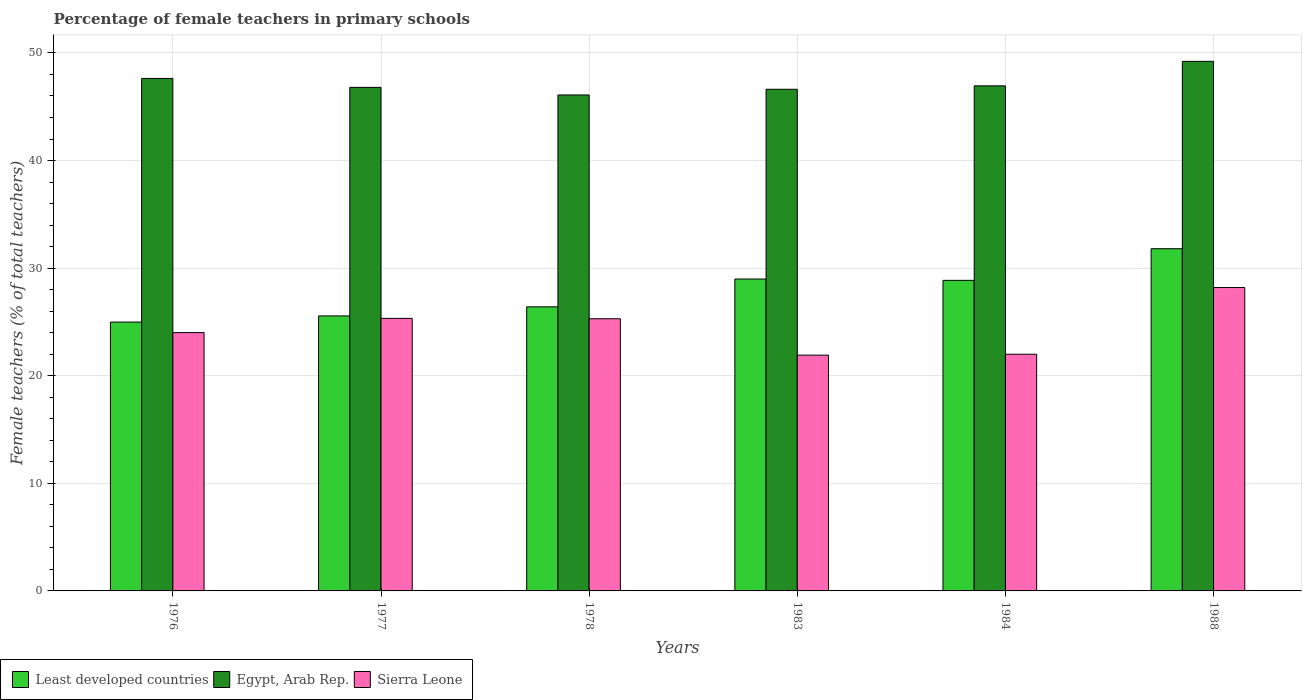How many different coloured bars are there?
Offer a terse response. 3. How many groups of bars are there?
Your answer should be compact. 6. Are the number of bars per tick equal to the number of legend labels?
Provide a short and direct response. Yes. Are the number of bars on each tick of the X-axis equal?
Provide a short and direct response. Yes. In how many cases, is the number of bars for a given year not equal to the number of legend labels?
Your answer should be compact. 0. What is the percentage of female teachers in Egypt, Arab Rep. in 1983?
Keep it short and to the point. 46.62. Across all years, what is the maximum percentage of female teachers in Sierra Leone?
Ensure brevity in your answer.  28.2. Across all years, what is the minimum percentage of female teachers in Least developed countries?
Provide a succinct answer. 24.98. In which year was the percentage of female teachers in Sierra Leone maximum?
Your answer should be very brief. 1988. In which year was the percentage of female teachers in Least developed countries minimum?
Give a very brief answer. 1976. What is the total percentage of female teachers in Sierra Leone in the graph?
Offer a terse response. 146.74. What is the difference between the percentage of female teachers in Egypt, Arab Rep. in 1977 and that in 1983?
Your response must be concise. 0.18. What is the difference between the percentage of female teachers in Least developed countries in 1977 and the percentage of female teachers in Egypt, Arab Rep. in 1976?
Your answer should be compact. -22.07. What is the average percentage of female teachers in Least developed countries per year?
Give a very brief answer. 27.77. In the year 1983, what is the difference between the percentage of female teachers in Egypt, Arab Rep. and percentage of female teachers in Least developed countries?
Your response must be concise. 17.64. In how many years, is the percentage of female teachers in Least developed countries greater than 34 %?
Your response must be concise. 0. What is the ratio of the percentage of female teachers in Sierra Leone in 1977 to that in 1983?
Give a very brief answer. 1.16. Is the difference between the percentage of female teachers in Egypt, Arab Rep. in 1976 and 1984 greater than the difference between the percentage of female teachers in Least developed countries in 1976 and 1984?
Provide a short and direct response. Yes. What is the difference between the highest and the second highest percentage of female teachers in Egypt, Arab Rep.?
Provide a short and direct response. 1.59. What is the difference between the highest and the lowest percentage of female teachers in Least developed countries?
Your response must be concise. 6.82. In how many years, is the percentage of female teachers in Sierra Leone greater than the average percentage of female teachers in Sierra Leone taken over all years?
Your answer should be very brief. 3. Is the sum of the percentage of female teachers in Least developed countries in 1977 and 1983 greater than the maximum percentage of female teachers in Sierra Leone across all years?
Your response must be concise. Yes. What does the 1st bar from the left in 1976 represents?
Your response must be concise. Least developed countries. What does the 2nd bar from the right in 1976 represents?
Give a very brief answer. Egypt, Arab Rep. What is the difference between two consecutive major ticks on the Y-axis?
Your answer should be very brief. 10. Does the graph contain any zero values?
Offer a very short reply. No. Does the graph contain grids?
Provide a succinct answer. Yes. Where does the legend appear in the graph?
Provide a short and direct response. Bottom left. How many legend labels are there?
Your response must be concise. 3. How are the legend labels stacked?
Ensure brevity in your answer.  Horizontal. What is the title of the graph?
Provide a succinct answer. Percentage of female teachers in primary schools. What is the label or title of the Y-axis?
Keep it short and to the point. Female teachers (% of total teachers). What is the Female teachers (% of total teachers) in Least developed countries in 1976?
Provide a short and direct response. 24.98. What is the Female teachers (% of total teachers) in Egypt, Arab Rep. in 1976?
Offer a terse response. 47.63. What is the Female teachers (% of total teachers) of Sierra Leone in 1976?
Make the answer very short. 24.01. What is the Female teachers (% of total teachers) in Least developed countries in 1977?
Your answer should be compact. 25.56. What is the Female teachers (% of total teachers) of Egypt, Arab Rep. in 1977?
Your answer should be very brief. 46.8. What is the Female teachers (% of total teachers) of Sierra Leone in 1977?
Keep it short and to the point. 25.33. What is the Female teachers (% of total teachers) in Least developed countries in 1978?
Your response must be concise. 26.4. What is the Female teachers (% of total teachers) of Egypt, Arab Rep. in 1978?
Ensure brevity in your answer.  46.09. What is the Female teachers (% of total teachers) in Sierra Leone in 1978?
Ensure brevity in your answer.  25.3. What is the Female teachers (% of total teachers) of Least developed countries in 1983?
Offer a terse response. 28.99. What is the Female teachers (% of total teachers) in Egypt, Arab Rep. in 1983?
Your answer should be compact. 46.62. What is the Female teachers (% of total teachers) in Sierra Leone in 1983?
Your answer should be very brief. 21.91. What is the Female teachers (% of total teachers) in Least developed countries in 1984?
Make the answer very short. 28.86. What is the Female teachers (% of total teachers) in Egypt, Arab Rep. in 1984?
Make the answer very short. 46.94. What is the Female teachers (% of total teachers) of Sierra Leone in 1984?
Your response must be concise. 22. What is the Female teachers (% of total teachers) in Least developed countries in 1988?
Your answer should be very brief. 31.8. What is the Female teachers (% of total teachers) in Egypt, Arab Rep. in 1988?
Provide a succinct answer. 49.22. What is the Female teachers (% of total teachers) in Sierra Leone in 1988?
Your answer should be compact. 28.2. Across all years, what is the maximum Female teachers (% of total teachers) in Least developed countries?
Provide a succinct answer. 31.8. Across all years, what is the maximum Female teachers (% of total teachers) of Egypt, Arab Rep.?
Your answer should be very brief. 49.22. Across all years, what is the maximum Female teachers (% of total teachers) in Sierra Leone?
Your answer should be compact. 28.2. Across all years, what is the minimum Female teachers (% of total teachers) in Least developed countries?
Keep it short and to the point. 24.98. Across all years, what is the minimum Female teachers (% of total teachers) in Egypt, Arab Rep.?
Keep it short and to the point. 46.09. Across all years, what is the minimum Female teachers (% of total teachers) of Sierra Leone?
Keep it short and to the point. 21.91. What is the total Female teachers (% of total teachers) of Least developed countries in the graph?
Ensure brevity in your answer.  166.6. What is the total Female teachers (% of total teachers) in Egypt, Arab Rep. in the graph?
Your answer should be compact. 283.3. What is the total Female teachers (% of total teachers) in Sierra Leone in the graph?
Offer a terse response. 146.74. What is the difference between the Female teachers (% of total teachers) in Least developed countries in 1976 and that in 1977?
Offer a very short reply. -0.57. What is the difference between the Female teachers (% of total teachers) in Egypt, Arab Rep. in 1976 and that in 1977?
Your response must be concise. 0.83. What is the difference between the Female teachers (% of total teachers) in Sierra Leone in 1976 and that in 1977?
Make the answer very short. -1.32. What is the difference between the Female teachers (% of total teachers) of Least developed countries in 1976 and that in 1978?
Ensure brevity in your answer.  -1.42. What is the difference between the Female teachers (% of total teachers) of Egypt, Arab Rep. in 1976 and that in 1978?
Give a very brief answer. 1.54. What is the difference between the Female teachers (% of total teachers) in Sierra Leone in 1976 and that in 1978?
Give a very brief answer. -1.29. What is the difference between the Female teachers (% of total teachers) of Least developed countries in 1976 and that in 1983?
Keep it short and to the point. -4. What is the difference between the Female teachers (% of total teachers) in Egypt, Arab Rep. in 1976 and that in 1983?
Keep it short and to the point. 1.01. What is the difference between the Female teachers (% of total teachers) of Sierra Leone in 1976 and that in 1983?
Your answer should be compact. 2.1. What is the difference between the Female teachers (% of total teachers) in Least developed countries in 1976 and that in 1984?
Offer a terse response. -3.88. What is the difference between the Female teachers (% of total teachers) in Egypt, Arab Rep. in 1976 and that in 1984?
Your answer should be very brief. 0.69. What is the difference between the Female teachers (% of total teachers) of Sierra Leone in 1976 and that in 1984?
Make the answer very short. 2.01. What is the difference between the Female teachers (% of total teachers) in Least developed countries in 1976 and that in 1988?
Your response must be concise. -6.82. What is the difference between the Female teachers (% of total teachers) of Egypt, Arab Rep. in 1976 and that in 1988?
Keep it short and to the point. -1.59. What is the difference between the Female teachers (% of total teachers) of Sierra Leone in 1976 and that in 1988?
Give a very brief answer. -4.19. What is the difference between the Female teachers (% of total teachers) of Least developed countries in 1977 and that in 1978?
Your answer should be compact. -0.84. What is the difference between the Female teachers (% of total teachers) of Egypt, Arab Rep. in 1977 and that in 1978?
Ensure brevity in your answer.  0.7. What is the difference between the Female teachers (% of total teachers) of Sierra Leone in 1977 and that in 1978?
Provide a succinct answer. 0.04. What is the difference between the Female teachers (% of total teachers) of Least developed countries in 1977 and that in 1983?
Your answer should be compact. -3.43. What is the difference between the Female teachers (% of total teachers) in Egypt, Arab Rep. in 1977 and that in 1983?
Provide a short and direct response. 0.18. What is the difference between the Female teachers (% of total teachers) in Sierra Leone in 1977 and that in 1983?
Offer a very short reply. 3.42. What is the difference between the Female teachers (% of total teachers) in Least developed countries in 1977 and that in 1984?
Your answer should be very brief. -3.31. What is the difference between the Female teachers (% of total teachers) of Egypt, Arab Rep. in 1977 and that in 1984?
Provide a short and direct response. -0.14. What is the difference between the Female teachers (% of total teachers) of Sierra Leone in 1977 and that in 1984?
Provide a succinct answer. 3.34. What is the difference between the Female teachers (% of total teachers) of Least developed countries in 1977 and that in 1988?
Offer a very short reply. -6.24. What is the difference between the Female teachers (% of total teachers) of Egypt, Arab Rep. in 1977 and that in 1988?
Ensure brevity in your answer.  -2.42. What is the difference between the Female teachers (% of total teachers) in Sierra Leone in 1977 and that in 1988?
Ensure brevity in your answer.  -2.87. What is the difference between the Female teachers (% of total teachers) of Least developed countries in 1978 and that in 1983?
Offer a very short reply. -2.58. What is the difference between the Female teachers (% of total teachers) of Egypt, Arab Rep. in 1978 and that in 1983?
Your answer should be very brief. -0.53. What is the difference between the Female teachers (% of total teachers) of Sierra Leone in 1978 and that in 1983?
Keep it short and to the point. 3.38. What is the difference between the Female teachers (% of total teachers) in Least developed countries in 1978 and that in 1984?
Make the answer very short. -2.46. What is the difference between the Female teachers (% of total teachers) in Egypt, Arab Rep. in 1978 and that in 1984?
Your answer should be very brief. -0.85. What is the difference between the Female teachers (% of total teachers) in Least developed countries in 1978 and that in 1988?
Provide a short and direct response. -5.4. What is the difference between the Female teachers (% of total teachers) in Egypt, Arab Rep. in 1978 and that in 1988?
Your answer should be compact. -3.12. What is the difference between the Female teachers (% of total teachers) of Sierra Leone in 1978 and that in 1988?
Your response must be concise. -2.9. What is the difference between the Female teachers (% of total teachers) in Least developed countries in 1983 and that in 1984?
Make the answer very short. 0.12. What is the difference between the Female teachers (% of total teachers) in Egypt, Arab Rep. in 1983 and that in 1984?
Your answer should be compact. -0.32. What is the difference between the Female teachers (% of total teachers) in Sierra Leone in 1983 and that in 1984?
Your answer should be compact. -0.08. What is the difference between the Female teachers (% of total teachers) of Least developed countries in 1983 and that in 1988?
Keep it short and to the point. -2.82. What is the difference between the Female teachers (% of total teachers) of Egypt, Arab Rep. in 1983 and that in 1988?
Your answer should be compact. -2.59. What is the difference between the Female teachers (% of total teachers) in Sierra Leone in 1983 and that in 1988?
Keep it short and to the point. -6.28. What is the difference between the Female teachers (% of total teachers) of Least developed countries in 1984 and that in 1988?
Give a very brief answer. -2.94. What is the difference between the Female teachers (% of total teachers) in Egypt, Arab Rep. in 1984 and that in 1988?
Provide a short and direct response. -2.28. What is the difference between the Female teachers (% of total teachers) in Sierra Leone in 1984 and that in 1988?
Keep it short and to the point. -6.2. What is the difference between the Female teachers (% of total teachers) in Least developed countries in 1976 and the Female teachers (% of total teachers) in Egypt, Arab Rep. in 1977?
Offer a terse response. -21.81. What is the difference between the Female teachers (% of total teachers) in Least developed countries in 1976 and the Female teachers (% of total teachers) in Sierra Leone in 1977?
Your answer should be very brief. -0.35. What is the difference between the Female teachers (% of total teachers) in Egypt, Arab Rep. in 1976 and the Female teachers (% of total teachers) in Sierra Leone in 1977?
Provide a short and direct response. 22.3. What is the difference between the Female teachers (% of total teachers) of Least developed countries in 1976 and the Female teachers (% of total teachers) of Egypt, Arab Rep. in 1978?
Provide a short and direct response. -21.11. What is the difference between the Female teachers (% of total teachers) in Least developed countries in 1976 and the Female teachers (% of total teachers) in Sierra Leone in 1978?
Ensure brevity in your answer.  -0.31. What is the difference between the Female teachers (% of total teachers) of Egypt, Arab Rep. in 1976 and the Female teachers (% of total teachers) of Sierra Leone in 1978?
Your response must be concise. 22.33. What is the difference between the Female teachers (% of total teachers) in Least developed countries in 1976 and the Female teachers (% of total teachers) in Egypt, Arab Rep. in 1983?
Provide a succinct answer. -21.64. What is the difference between the Female teachers (% of total teachers) of Least developed countries in 1976 and the Female teachers (% of total teachers) of Sierra Leone in 1983?
Provide a short and direct response. 3.07. What is the difference between the Female teachers (% of total teachers) of Egypt, Arab Rep. in 1976 and the Female teachers (% of total teachers) of Sierra Leone in 1983?
Provide a succinct answer. 25.72. What is the difference between the Female teachers (% of total teachers) of Least developed countries in 1976 and the Female teachers (% of total teachers) of Egypt, Arab Rep. in 1984?
Give a very brief answer. -21.96. What is the difference between the Female teachers (% of total teachers) in Least developed countries in 1976 and the Female teachers (% of total teachers) in Sierra Leone in 1984?
Your response must be concise. 2.99. What is the difference between the Female teachers (% of total teachers) of Egypt, Arab Rep. in 1976 and the Female teachers (% of total teachers) of Sierra Leone in 1984?
Provide a short and direct response. 25.63. What is the difference between the Female teachers (% of total teachers) of Least developed countries in 1976 and the Female teachers (% of total teachers) of Egypt, Arab Rep. in 1988?
Offer a very short reply. -24.23. What is the difference between the Female teachers (% of total teachers) in Least developed countries in 1976 and the Female teachers (% of total teachers) in Sierra Leone in 1988?
Your answer should be compact. -3.21. What is the difference between the Female teachers (% of total teachers) of Egypt, Arab Rep. in 1976 and the Female teachers (% of total teachers) of Sierra Leone in 1988?
Make the answer very short. 19.43. What is the difference between the Female teachers (% of total teachers) of Least developed countries in 1977 and the Female teachers (% of total teachers) of Egypt, Arab Rep. in 1978?
Your answer should be compact. -20.53. What is the difference between the Female teachers (% of total teachers) in Least developed countries in 1977 and the Female teachers (% of total teachers) in Sierra Leone in 1978?
Give a very brief answer. 0.26. What is the difference between the Female teachers (% of total teachers) in Egypt, Arab Rep. in 1977 and the Female teachers (% of total teachers) in Sierra Leone in 1978?
Ensure brevity in your answer.  21.5. What is the difference between the Female teachers (% of total teachers) of Least developed countries in 1977 and the Female teachers (% of total teachers) of Egypt, Arab Rep. in 1983?
Make the answer very short. -21.06. What is the difference between the Female teachers (% of total teachers) of Least developed countries in 1977 and the Female teachers (% of total teachers) of Sierra Leone in 1983?
Your answer should be very brief. 3.65. What is the difference between the Female teachers (% of total teachers) in Egypt, Arab Rep. in 1977 and the Female teachers (% of total teachers) in Sierra Leone in 1983?
Provide a short and direct response. 24.89. What is the difference between the Female teachers (% of total teachers) of Least developed countries in 1977 and the Female teachers (% of total teachers) of Egypt, Arab Rep. in 1984?
Keep it short and to the point. -21.38. What is the difference between the Female teachers (% of total teachers) of Least developed countries in 1977 and the Female teachers (% of total teachers) of Sierra Leone in 1984?
Keep it short and to the point. 3.56. What is the difference between the Female teachers (% of total teachers) of Egypt, Arab Rep. in 1977 and the Female teachers (% of total teachers) of Sierra Leone in 1984?
Ensure brevity in your answer.  24.8. What is the difference between the Female teachers (% of total teachers) of Least developed countries in 1977 and the Female teachers (% of total teachers) of Egypt, Arab Rep. in 1988?
Provide a short and direct response. -23.66. What is the difference between the Female teachers (% of total teachers) of Least developed countries in 1977 and the Female teachers (% of total teachers) of Sierra Leone in 1988?
Provide a short and direct response. -2.64. What is the difference between the Female teachers (% of total teachers) of Egypt, Arab Rep. in 1977 and the Female teachers (% of total teachers) of Sierra Leone in 1988?
Make the answer very short. 18.6. What is the difference between the Female teachers (% of total teachers) in Least developed countries in 1978 and the Female teachers (% of total teachers) in Egypt, Arab Rep. in 1983?
Your response must be concise. -20.22. What is the difference between the Female teachers (% of total teachers) in Least developed countries in 1978 and the Female teachers (% of total teachers) in Sierra Leone in 1983?
Provide a short and direct response. 4.49. What is the difference between the Female teachers (% of total teachers) of Egypt, Arab Rep. in 1978 and the Female teachers (% of total teachers) of Sierra Leone in 1983?
Give a very brief answer. 24.18. What is the difference between the Female teachers (% of total teachers) of Least developed countries in 1978 and the Female teachers (% of total teachers) of Egypt, Arab Rep. in 1984?
Make the answer very short. -20.54. What is the difference between the Female teachers (% of total teachers) in Least developed countries in 1978 and the Female teachers (% of total teachers) in Sierra Leone in 1984?
Offer a very short reply. 4.41. What is the difference between the Female teachers (% of total teachers) of Egypt, Arab Rep. in 1978 and the Female teachers (% of total teachers) of Sierra Leone in 1984?
Your response must be concise. 24.1. What is the difference between the Female teachers (% of total teachers) of Least developed countries in 1978 and the Female teachers (% of total teachers) of Egypt, Arab Rep. in 1988?
Your answer should be very brief. -22.81. What is the difference between the Female teachers (% of total teachers) in Least developed countries in 1978 and the Female teachers (% of total teachers) in Sierra Leone in 1988?
Provide a succinct answer. -1.79. What is the difference between the Female teachers (% of total teachers) in Egypt, Arab Rep. in 1978 and the Female teachers (% of total teachers) in Sierra Leone in 1988?
Offer a very short reply. 17.9. What is the difference between the Female teachers (% of total teachers) in Least developed countries in 1983 and the Female teachers (% of total teachers) in Egypt, Arab Rep. in 1984?
Keep it short and to the point. -17.95. What is the difference between the Female teachers (% of total teachers) in Least developed countries in 1983 and the Female teachers (% of total teachers) in Sierra Leone in 1984?
Provide a succinct answer. 6.99. What is the difference between the Female teachers (% of total teachers) in Egypt, Arab Rep. in 1983 and the Female teachers (% of total teachers) in Sierra Leone in 1984?
Your response must be concise. 24.63. What is the difference between the Female teachers (% of total teachers) of Least developed countries in 1983 and the Female teachers (% of total teachers) of Egypt, Arab Rep. in 1988?
Your answer should be very brief. -20.23. What is the difference between the Female teachers (% of total teachers) of Least developed countries in 1983 and the Female teachers (% of total teachers) of Sierra Leone in 1988?
Your answer should be compact. 0.79. What is the difference between the Female teachers (% of total teachers) in Egypt, Arab Rep. in 1983 and the Female teachers (% of total teachers) in Sierra Leone in 1988?
Give a very brief answer. 18.43. What is the difference between the Female teachers (% of total teachers) in Least developed countries in 1984 and the Female teachers (% of total teachers) in Egypt, Arab Rep. in 1988?
Provide a short and direct response. -20.35. What is the difference between the Female teachers (% of total teachers) in Least developed countries in 1984 and the Female teachers (% of total teachers) in Sierra Leone in 1988?
Your answer should be compact. 0.67. What is the difference between the Female teachers (% of total teachers) in Egypt, Arab Rep. in 1984 and the Female teachers (% of total teachers) in Sierra Leone in 1988?
Your answer should be compact. 18.74. What is the average Female teachers (% of total teachers) in Least developed countries per year?
Provide a short and direct response. 27.77. What is the average Female teachers (% of total teachers) in Egypt, Arab Rep. per year?
Keep it short and to the point. 47.22. What is the average Female teachers (% of total teachers) of Sierra Leone per year?
Provide a short and direct response. 24.46. In the year 1976, what is the difference between the Female teachers (% of total teachers) of Least developed countries and Female teachers (% of total teachers) of Egypt, Arab Rep.?
Provide a short and direct response. -22.65. In the year 1976, what is the difference between the Female teachers (% of total teachers) in Least developed countries and Female teachers (% of total teachers) in Sierra Leone?
Provide a succinct answer. 0.98. In the year 1976, what is the difference between the Female teachers (% of total teachers) in Egypt, Arab Rep. and Female teachers (% of total teachers) in Sierra Leone?
Your answer should be very brief. 23.62. In the year 1977, what is the difference between the Female teachers (% of total teachers) of Least developed countries and Female teachers (% of total teachers) of Egypt, Arab Rep.?
Your answer should be very brief. -21.24. In the year 1977, what is the difference between the Female teachers (% of total teachers) in Least developed countries and Female teachers (% of total teachers) in Sierra Leone?
Offer a very short reply. 0.23. In the year 1977, what is the difference between the Female teachers (% of total teachers) of Egypt, Arab Rep. and Female teachers (% of total teachers) of Sierra Leone?
Provide a short and direct response. 21.47. In the year 1978, what is the difference between the Female teachers (% of total teachers) of Least developed countries and Female teachers (% of total teachers) of Egypt, Arab Rep.?
Offer a terse response. -19.69. In the year 1978, what is the difference between the Female teachers (% of total teachers) of Least developed countries and Female teachers (% of total teachers) of Sierra Leone?
Your answer should be very brief. 1.11. In the year 1978, what is the difference between the Female teachers (% of total teachers) of Egypt, Arab Rep. and Female teachers (% of total teachers) of Sierra Leone?
Offer a very short reply. 20.8. In the year 1983, what is the difference between the Female teachers (% of total teachers) of Least developed countries and Female teachers (% of total teachers) of Egypt, Arab Rep.?
Offer a terse response. -17.64. In the year 1983, what is the difference between the Female teachers (% of total teachers) in Least developed countries and Female teachers (% of total teachers) in Sierra Leone?
Provide a short and direct response. 7.07. In the year 1983, what is the difference between the Female teachers (% of total teachers) in Egypt, Arab Rep. and Female teachers (% of total teachers) in Sierra Leone?
Your response must be concise. 24.71. In the year 1984, what is the difference between the Female teachers (% of total teachers) in Least developed countries and Female teachers (% of total teachers) in Egypt, Arab Rep.?
Your response must be concise. -18.08. In the year 1984, what is the difference between the Female teachers (% of total teachers) of Least developed countries and Female teachers (% of total teachers) of Sierra Leone?
Your response must be concise. 6.87. In the year 1984, what is the difference between the Female teachers (% of total teachers) of Egypt, Arab Rep. and Female teachers (% of total teachers) of Sierra Leone?
Give a very brief answer. 24.94. In the year 1988, what is the difference between the Female teachers (% of total teachers) of Least developed countries and Female teachers (% of total teachers) of Egypt, Arab Rep.?
Provide a short and direct response. -17.41. In the year 1988, what is the difference between the Female teachers (% of total teachers) of Least developed countries and Female teachers (% of total teachers) of Sierra Leone?
Provide a short and direct response. 3.61. In the year 1988, what is the difference between the Female teachers (% of total teachers) of Egypt, Arab Rep. and Female teachers (% of total teachers) of Sierra Leone?
Your answer should be compact. 21.02. What is the ratio of the Female teachers (% of total teachers) of Least developed countries in 1976 to that in 1977?
Your response must be concise. 0.98. What is the ratio of the Female teachers (% of total teachers) of Egypt, Arab Rep. in 1976 to that in 1977?
Provide a short and direct response. 1.02. What is the ratio of the Female teachers (% of total teachers) of Sierra Leone in 1976 to that in 1977?
Provide a succinct answer. 0.95. What is the ratio of the Female teachers (% of total teachers) of Least developed countries in 1976 to that in 1978?
Your answer should be compact. 0.95. What is the ratio of the Female teachers (% of total teachers) in Sierra Leone in 1976 to that in 1978?
Your answer should be very brief. 0.95. What is the ratio of the Female teachers (% of total teachers) in Least developed countries in 1976 to that in 1983?
Provide a succinct answer. 0.86. What is the ratio of the Female teachers (% of total teachers) of Egypt, Arab Rep. in 1976 to that in 1983?
Provide a short and direct response. 1.02. What is the ratio of the Female teachers (% of total teachers) of Sierra Leone in 1976 to that in 1983?
Keep it short and to the point. 1.1. What is the ratio of the Female teachers (% of total teachers) of Least developed countries in 1976 to that in 1984?
Offer a terse response. 0.87. What is the ratio of the Female teachers (% of total teachers) in Egypt, Arab Rep. in 1976 to that in 1984?
Make the answer very short. 1.01. What is the ratio of the Female teachers (% of total teachers) of Sierra Leone in 1976 to that in 1984?
Your answer should be very brief. 1.09. What is the ratio of the Female teachers (% of total teachers) in Least developed countries in 1976 to that in 1988?
Give a very brief answer. 0.79. What is the ratio of the Female teachers (% of total teachers) in Egypt, Arab Rep. in 1976 to that in 1988?
Provide a short and direct response. 0.97. What is the ratio of the Female teachers (% of total teachers) of Sierra Leone in 1976 to that in 1988?
Keep it short and to the point. 0.85. What is the ratio of the Female teachers (% of total teachers) in Egypt, Arab Rep. in 1977 to that in 1978?
Keep it short and to the point. 1.02. What is the ratio of the Female teachers (% of total teachers) in Least developed countries in 1977 to that in 1983?
Make the answer very short. 0.88. What is the ratio of the Female teachers (% of total teachers) of Egypt, Arab Rep. in 1977 to that in 1983?
Your answer should be compact. 1. What is the ratio of the Female teachers (% of total teachers) of Sierra Leone in 1977 to that in 1983?
Ensure brevity in your answer.  1.16. What is the ratio of the Female teachers (% of total teachers) in Least developed countries in 1977 to that in 1984?
Offer a terse response. 0.89. What is the ratio of the Female teachers (% of total teachers) in Egypt, Arab Rep. in 1977 to that in 1984?
Your response must be concise. 1. What is the ratio of the Female teachers (% of total teachers) in Sierra Leone in 1977 to that in 1984?
Give a very brief answer. 1.15. What is the ratio of the Female teachers (% of total teachers) of Least developed countries in 1977 to that in 1988?
Keep it short and to the point. 0.8. What is the ratio of the Female teachers (% of total teachers) of Egypt, Arab Rep. in 1977 to that in 1988?
Ensure brevity in your answer.  0.95. What is the ratio of the Female teachers (% of total teachers) of Sierra Leone in 1977 to that in 1988?
Provide a short and direct response. 0.9. What is the ratio of the Female teachers (% of total teachers) in Least developed countries in 1978 to that in 1983?
Keep it short and to the point. 0.91. What is the ratio of the Female teachers (% of total teachers) of Egypt, Arab Rep. in 1978 to that in 1983?
Provide a succinct answer. 0.99. What is the ratio of the Female teachers (% of total teachers) in Sierra Leone in 1978 to that in 1983?
Provide a succinct answer. 1.15. What is the ratio of the Female teachers (% of total teachers) of Least developed countries in 1978 to that in 1984?
Make the answer very short. 0.91. What is the ratio of the Female teachers (% of total teachers) of Sierra Leone in 1978 to that in 1984?
Give a very brief answer. 1.15. What is the ratio of the Female teachers (% of total teachers) of Least developed countries in 1978 to that in 1988?
Give a very brief answer. 0.83. What is the ratio of the Female teachers (% of total teachers) in Egypt, Arab Rep. in 1978 to that in 1988?
Your response must be concise. 0.94. What is the ratio of the Female teachers (% of total teachers) of Sierra Leone in 1978 to that in 1988?
Offer a terse response. 0.9. What is the ratio of the Female teachers (% of total teachers) in Least developed countries in 1983 to that in 1984?
Give a very brief answer. 1. What is the ratio of the Female teachers (% of total teachers) in Least developed countries in 1983 to that in 1988?
Keep it short and to the point. 0.91. What is the ratio of the Female teachers (% of total teachers) of Egypt, Arab Rep. in 1983 to that in 1988?
Provide a short and direct response. 0.95. What is the ratio of the Female teachers (% of total teachers) of Sierra Leone in 1983 to that in 1988?
Make the answer very short. 0.78. What is the ratio of the Female teachers (% of total teachers) in Least developed countries in 1984 to that in 1988?
Make the answer very short. 0.91. What is the ratio of the Female teachers (% of total teachers) of Egypt, Arab Rep. in 1984 to that in 1988?
Make the answer very short. 0.95. What is the ratio of the Female teachers (% of total teachers) of Sierra Leone in 1984 to that in 1988?
Your response must be concise. 0.78. What is the difference between the highest and the second highest Female teachers (% of total teachers) of Least developed countries?
Ensure brevity in your answer.  2.82. What is the difference between the highest and the second highest Female teachers (% of total teachers) of Egypt, Arab Rep.?
Offer a terse response. 1.59. What is the difference between the highest and the second highest Female teachers (% of total teachers) of Sierra Leone?
Ensure brevity in your answer.  2.87. What is the difference between the highest and the lowest Female teachers (% of total teachers) in Least developed countries?
Your answer should be compact. 6.82. What is the difference between the highest and the lowest Female teachers (% of total teachers) of Egypt, Arab Rep.?
Offer a very short reply. 3.12. What is the difference between the highest and the lowest Female teachers (% of total teachers) in Sierra Leone?
Your answer should be compact. 6.28. 